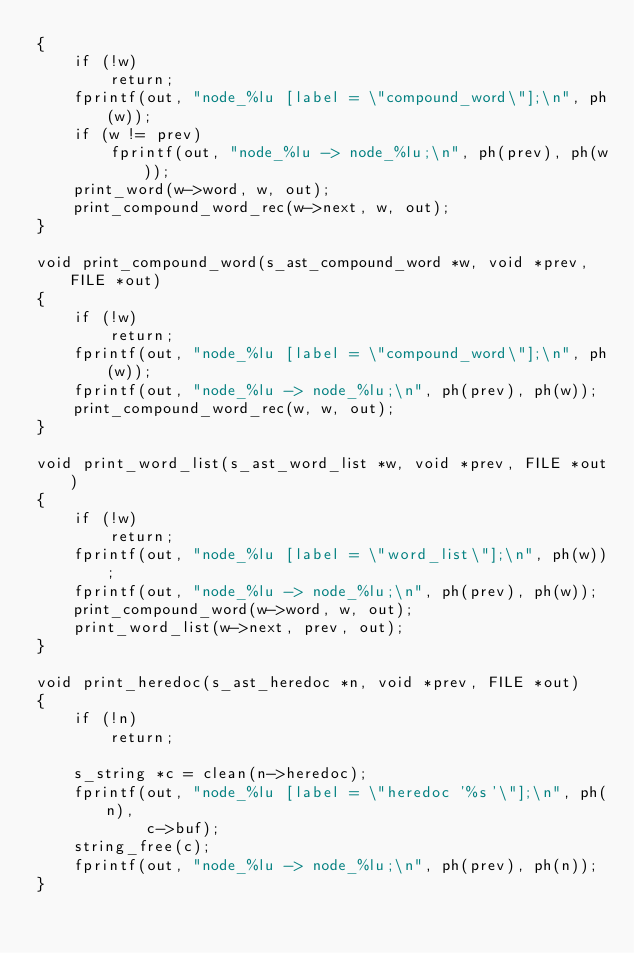Convert code to text. <code><loc_0><loc_0><loc_500><loc_500><_C_>{
    if (!w)
        return;
    fprintf(out, "node_%lu [label = \"compound_word\"];\n", ph(w));
    if (w != prev)
        fprintf(out, "node_%lu -> node_%lu;\n", ph(prev), ph(w));
    print_word(w->word, w, out);
    print_compound_word_rec(w->next, w, out);
}

void print_compound_word(s_ast_compound_word *w, void *prev, FILE *out)
{
    if (!w)
        return;
    fprintf(out, "node_%lu [label = \"compound_word\"];\n", ph(w));
    fprintf(out, "node_%lu -> node_%lu;\n", ph(prev), ph(w));
    print_compound_word_rec(w, w, out);
}

void print_word_list(s_ast_word_list *w, void *prev, FILE *out)
{
    if (!w)
        return;
    fprintf(out, "node_%lu [label = \"word_list\"];\n", ph(w));
    fprintf(out, "node_%lu -> node_%lu;\n", ph(prev), ph(w));
    print_compound_word(w->word, w, out);
    print_word_list(w->next, prev, out);
}

void print_heredoc(s_ast_heredoc *n, void *prev, FILE *out)
{
    if (!n)
        return;

    s_string *c = clean(n->heredoc);
    fprintf(out, "node_%lu [label = \"heredoc '%s'\"];\n", ph(n),
            c->buf);
    string_free(c);
    fprintf(out, "node_%lu -> node_%lu;\n", ph(prev), ph(n));
}
</code> 